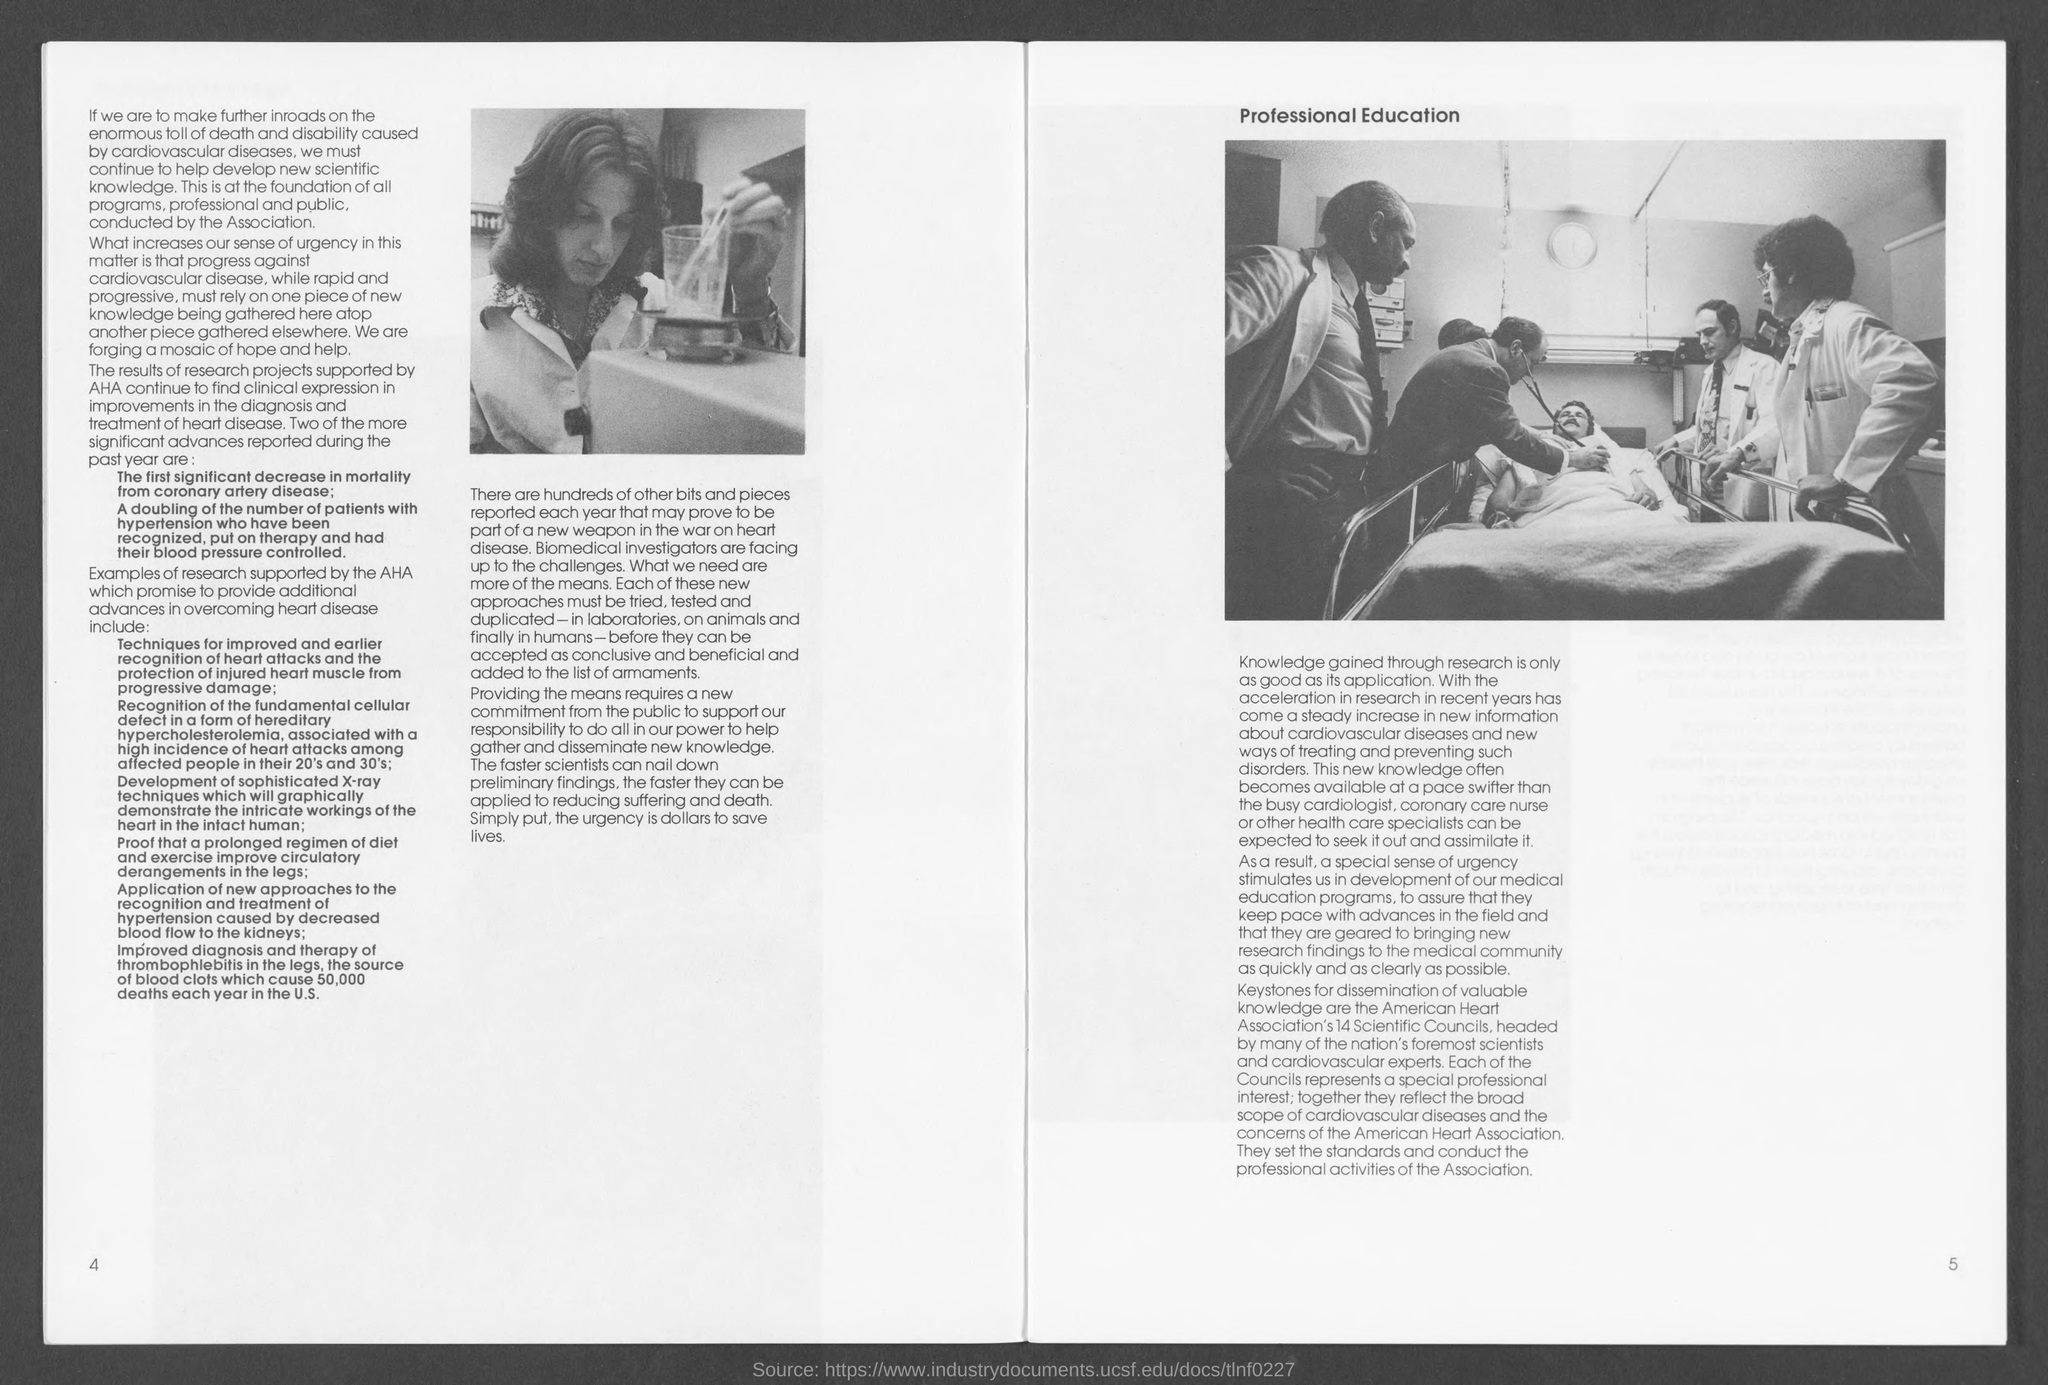Indicate a few pertinent items in this graphic. The number at the bottom left page is 4. What is the number at the bottom right side? 